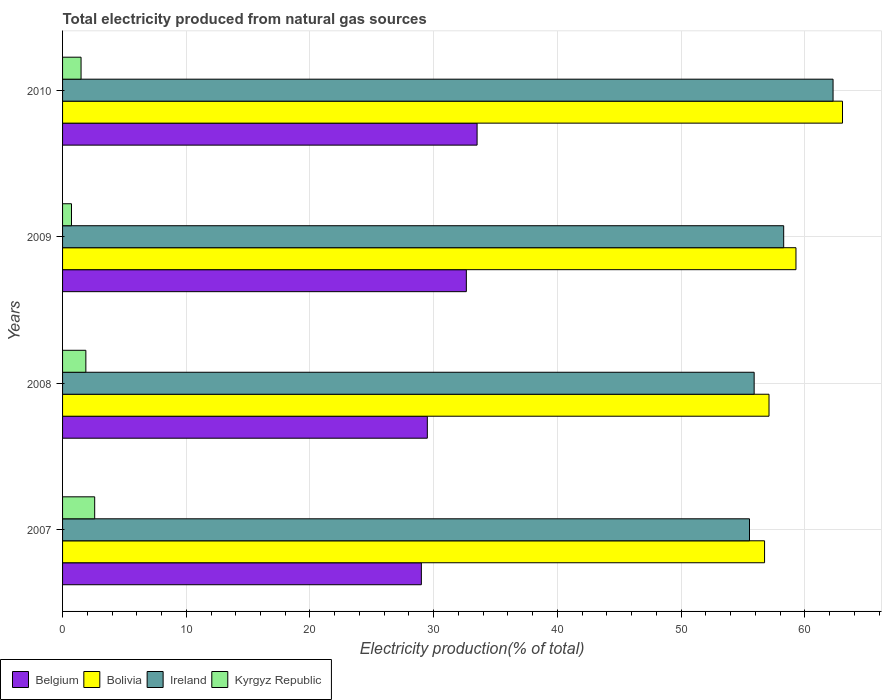Are the number of bars per tick equal to the number of legend labels?
Your response must be concise. Yes. Are the number of bars on each tick of the Y-axis equal?
Your answer should be compact. Yes. How many bars are there on the 3rd tick from the top?
Make the answer very short. 4. In how many cases, is the number of bars for a given year not equal to the number of legend labels?
Offer a terse response. 0. What is the total electricity produced in Bolivia in 2008?
Provide a succinct answer. 57.11. Across all years, what is the maximum total electricity produced in Bolivia?
Offer a terse response. 63.05. Across all years, what is the minimum total electricity produced in Belgium?
Make the answer very short. 29. In which year was the total electricity produced in Kyrgyz Republic maximum?
Provide a succinct answer. 2007. In which year was the total electricity produced in Belgium minimum?
Give a very brief answer. 2007. What is the total total electricity produced in Belgium in the graph?
Offer a terse response. 124.64. What is the difference between the total electricity produced in Kyrgyz Republic in 2007 and that in 2010?
Give a very brief answer. 1.1. What is the difference between the total electricity produced in Bolivia in 2008 and the total electricity produced in Belgium in 2007?
Your answer should be very brief. 28.1. What is the average total electricity produced in Belgium per year?
Your response must be concise. 31.16. In the year 2010, what is the difference between the total electricity produced in Bolivia and total electricity produced in Kyrgyz Republic?
Your answer should be compact. 61.55. What is the ratio of the total electricity produced in Bolivia in 2009 to that in 2010?
Your response must be concise. 0.94. Is the difference between the total electricity produced in Bolivia in 2007 and 2008 greater than the difference between the total electricity produced in Kyrgyz Republic in 2007 and 2008?
Make the answer very short. No. What is the difference between the highest and the second highest total electricity produced in Belgium?
Provide a short and direct response. 0.87. What is the difference between the highest and the lowest total electricity produced in Bolivia?
Keep it short and to the point. 6.3. Is it the case that in every year, the sum of the total electricity produced in Belgium and total electricity produced in Ireland is greater than the sum of total electricity produced in Kyrgyz Republic and total electricity produced in Bolivia?
Provide a short and direct response. Yes. What does the 1st bar from the bottom in 2009 represents?
Give a very brief answer. Belgium. How many bars are there?
Provide a short and direct response. 16. How many years are there in the graph?
Offer a very short reply. 4. What is the difference between two consecutive major ticks on the X-axis?
Make the answer very short. 10. Does the graph contain any zero values?
Offer a very short reply. No. Where does the legend appear in the graph?
Your answer should be very brief. Bottom left. How many legend labels are there?
Give a very brief answer. 4. How are the legend labels stacked?
Ensure brevity in your answer.  Horizontal. What is the title of the graph?
Provide a short and direct response. Total electricity produced from natural gas sources. What is the label or title of the X-axis?
Offer a terse response. Electricity production(% of total). What is the Electricity production(% of total) in Belgium in 2007?
Ensure brevity in your answer.  29. What is the Electricity production(% of total) in Bolivia in 2007?
Keep it short and to the point. 56.75. What is the Electricity production(% of total) of Ireland in 2007?
Your answer should be compact. 55.53. What is the Electricity production(% of total) in Kyrgyz Republic in 2007?
Your response must be concise. 2.6. What is the Electricity production(% of total) in Belgium in 2008?
Offer a very short reply. 29.49. What is the Electricity production(% of total) in Bolivia in 2008?
Your answer should be compact. 57.11. What is the Electricity production(% of total) of Ireland in 2008?
Offer a terse response. 55.91. What is the Electricity production(% of total) in Kyrgyz Republic in 2008?
Your answer should be compact. 1.88. What is the Electricity production(% of total) of Belgium in 2009?
Your answer should be compact. 32.64. What is the Electricity production(% of total) in Bolivia in 2009?
Make the answer very short. 59.29. What is the Electricity production(% of total) of Ireland in 2009?
Your answer should be very brief. 58.29. What is the Electricity production(% of total) in Kyrgyz Republic in 2009?
Offer a terse response. 0.72. What is the Electricity production(% of total) in Belgium in 2010?
Provide a short and direct response. 33.51. What is the Electricity production(% of total) in Bolivia in 2010?
Keep it short and to the point. 63.05. What is the Electricity production(% of total) in Ireland in 2010?
Provide a succinct answer. 62.29. What is the Electricity production(% of total) of Kyrgyz Republic in 2010?
Provide a succinct answer. 1.5. Across all years, what is the maximum Electricity production(% of total) in Belgium?
Keep it short and to the point. 33.51. Across all years, what is the maximum Electricity production(% of total) in Bolivia?
Offer a terse response. 63.05. Across all years, what is the maximum Electricity production(% of total) in Ireland?
Ensure brevity in your answer.  62.29. Across all years, what is the maximum Electricity production(% of total) of Kyrgyz Republic?
Keep it short and to the point. 2.6. Across all years, what is the minimum Electricity production(% of total) of Belgium?
Ensure brevity in your answer.  29. Across all years, what is the minimum Electricity production(% of total) in Bolivia?
Your answer should be compact. 56.75. Across all years, what is the minimum Electricity production(% of total) of Ireland?
Keep it short and to the point. 55.53. Across all years, what is the minimum Electricity production(% of total) in Kyrgyz Republic?
Your answer should be compact. 0.72. What is the total Electricity production(% of total) of Belgium in the graph?
Ensure brevity in your answer.  124.64. What is the total Electricity production(% of total) in Bolivia in the graph?
Make the answer very short. 236.19. What is the total Electricity production(% of total) in Ireland in the graph?
Provide a short and direct response. 232.02. What is the total Electricity production(% of total) in Kyrgyz Republic in the graph?
Ensure brevity in your answer.  6.7. What is the difference between the Electricity production(% of total) of Belgium in 2007 and that in 2008?
Your answer should be very brief. -0.48. What is the difference between the Electricity production(% of total) in Bolivia in 2007 and that in 2008?
Provide a short and direct response. -0.36. What is the difference between the Electricity production(% of total) of Ireland in 2007 and that in 2008?
Make the answer very short. -0.38. What is the difference between the Electricity production(% of total) in Kyrgyz Republic in 2007 and that in 2008?
Your answer should be very brief. 0.71. What is the difference between the Electricity production(% of total) of Belgium in 2007 and that in 2009?
Provide a succinct answer. -3.64. What is the difference between the Electricity production(% of total) of Bolivia in 2007 and that in 2009?
Offer a very short reply. -2.54. What is the difference between the Electricity production(% of total) of Ireland in 2007 and that in 2009?
Offer a very short reply. -2.76. What is the difference between the Electricity production(% of total) in Kyrgyz Republic in 2007 and that in 2009?
Your response must be concise. 1.87. What is the difference between the Electricity production(% of total) of Belgium in 2007 and that in 2010?
Ensure brevity in your answer.  -4.51. What is the difference between the Electricity production(% of total) in Bolivia in 2007 and that in 2010?
Ensure brevity in your answer.  -6.3. What is the difference between the Electricity production(% of total) in Ireland in 2007 and that in 2010?
Your answer should be compact. -6.76. What is the difference between the Electricity production(% of total) of Kyrgyz Republic in 2007 and that in 2010?
Make the answer very short. 1.1. What is the difference between the Electricity production(% of total) of Belgium in 2008 and that in 2009?
Give a very brief answer. -3.15. What is the difference between the Electricity production(% of total) in Bolivia in 2008 and that in 2009?
Give a very brief answer. -2.18. What is the difference between the Electricity production(% of total) of Ireland in 2008 and that in 2009?
Make the answer very short. -2.39. What is the difference between the Electricity production(% of total) in Kyrgyz Republic in 2008 and that in 2009?
Your answer should be very brief. 1.16. What is the difference between the Electricity production(% of total) of Belgium in 2008 and that in 2010?
Your response must be concise. -4.02. What is the difference between the Electricity production(% of total) of Bolivia in 2008 and that in 2010?
Your response must be concise. -5.94. What is the difference between the Electricity production(% of total) of Ireland in 2008 and that in 2010?
Offer a very short reply. -6.38. What is the difference between the Electricity production(% of total) in Kyrgyz Republic in 2008 and that in 2010?
Your response must be concise. 0.39. What is the difference between the Electricity production(% of total) of Belgium in 2009 and that in 2010?
Your answer should be compact. -0.87. What is the difference between the Electricity production(% of total) of Bolivia in 2009 and that in 2010?
Provide a succinct answer. -3.76. What is the difference between the Electricity production(% of total) of Ireland in 2009 and that in 2010?
Offer a very short reply. -3.99. What is the difference between the Electricity production(% of total) in Kyrgyz Republic in 2009 and that in 2010?
Make the answer very short. -0.77. What is the difference between the Electricity production(% of total) of Belgium in 2007 and the Electricity production(% of total) of Bolivia in 2008?
Your answer should be very brief. -28.1. What is the difference between the Electricity production(% of total) of Belgium in 2007 and the Electricity production(% of total) of Ireland in 2008?
Offer a very short reply. -26.9. What is the difference between the Electricity production(% of total) of Belgium in 2007 and the Electricity production(% of total) of Kyrgyz Republic in 2008?
Make the answer very short. 27.12. What is the difference between the Electricity production(% of total) in Bolivia in 2007 and the Electricity production(% of total) in Ireland in 2008?
Make the answer very short. 0.84. What is the difference between the Electricity production(% of total) of Bolivia in 2007 and the Electricity production(% of total) of Kyrgyz Republic in 2008?
Provide a short and direct response. 54.87. What is the difference between the Electricity production(% of total) of Ireland in 2007 and the Electricity production(% of total) of Kyrgyz Republic in 2008?
Offer a terse response. 53.65. What is the difference between the Electricity production(% of total) of Belgium in 2007 and the Electricity production(% of total) of Bolivia in 2009?
Provide a short and direct response. -30.28. What is the difference between the Electricity production(% of total) of Belgium in 2007 and the Electricity production(% of total) of Ireland in 2009?
Ensure brevity in your answer.  -29.29. What is the difference between the Electricity production(% of total) of Belgium in 2007 and the Electricity production(% of total) of Kyrgyz Republic in 2009?
Your answer should be compact. 28.28. What is the difference between the Electricity production(% of total) of Bolivia in 2007 and the Electricity production(% of total) of Ireland in 2009?
Your answer should be compact. -1.55. What is the difference between the Electricity production(% of total) of Bolivia in 2007 and the Electricity production(% of total) of Kyrgyz Republic in 2009?
Make the answer very short. 56.03. What is the difference between the Electricity production(% of total) in Ireland in 2007 and the Electricity production(% of total) in Kyrgyz Republic in 2009?
Your response must be concise. 54.81. What is the difference between the Electricity production(% of total) of Belgium in 2007 and the Electricity production(% of total) of Bolivia in 2010?
Make the answer very short. -34.04. What is the difference between the Electricity production(% of total) in Belgium in 2007 and the Electricity production(% of total) in Ireland in 2010?
Ensure brevity in your answer.  -33.28. What is the difference between the Electricity production(% of total) of Belgium in 2007 and the Electricity production(% of total) of Kyrgyz Republic in 2010?
Your answer should be compact. 27.51. What is the difference between the Electricity production(% of total) of Bolivia in 2007 and the Electricity production(% of total) of Ireland in 2010?
Your answer should be compact. -5.54. What is the difference between the Electricity production(% of total) of Bolivia in 2007 and the Electricity production(% of total) of Kyrgyz Republic in 2010?
Keep it short and to the point. 55.25. What is the difference between the Electricity production(% of total) in Ireland in 2007 and the Electricity production(% of total) in Kyrgyz Republic in 2010?
Your answer should be very brief. 54.04. What is the difference between the Electricity production(% of total) of Belgium in 2008 and the Electricity production(% of total) of Bolivia in 2009?
Your response must be concise. -29.8. What is the difference between the Electricity production(% of total) in Belgium in 2008 and the Electricity production(% of total) in Ireland in 2009?
Keep it short and to the point. -28.81. What is the difference between the Electricity production(% of total) of Belgium in 2008 and the Electricity production(% of total) of Kyrgyz Republic in 2009?
Make the answer very short. 28.77. What is the difference between the Electricity production(% of total) in Bolivia in 2008 and the Electricity production(% of total) in Ireland in 2009?
Provide a succinct answer. -1.19. What is the difference between the Electricity production(% of total) of Bolivia in 2008 and the Electricity production(% of total) of Kyrgyz Republic in 2009?
Provide a succinct answer. 56.39. What is the difference between the Electricity production(% of total) in Ireland in 2008 and the Electricity production(% of total) in Kyrgyz Republic in 2009?
Your answer should be compact. 55.19. What is the difference between the Electricity production(% of total) of Belgium in 2008 and the Electricity production(% of total) of Bolivia in 2010?
Give a very brief answer. -33.56. What is the difference between the Electricity production(% of total) of Belgium in 2008 and the Electricity production(% of total) of Ireland in 2010?
Your response must be concise. -32.8. What is the difference between the Electricity production(% of total) in Belgium in 2008 and the Electricity production(% of total) in Kyrgyz Republic in 2010?
Offer a very short reply. 27.99. What is the difference between the Electricity production(% of total) of Bolivia in 2008 and the Electricity production(% of total) of Ireland in 2010?
Your answer should be very brief. -5.18. What is the difference between the Electricity production(% of total) of Bolivia in 2008 and the Electricity production(% of total) of Kyrgyz Republic in 2010?
Your answer should be compact. 55.61. What is the difference between the Electricity production(% of total) of Ireland in 2008 and the Electricity production(% of total) of Kyrgyz Republic in 2010?
Keep it short and to the point. 54.41. What is the difference between the Electricity production(% of total) of Belgium in 2009 and the Electricity production(% of total) of Bolivia in 2010?
Provide a succinct answer. -30.41. What is the difference between the Electricity production(% of total) in Belgium in 2009 and the Electricity production(% of total) in Ireland in 2010?
Give a very brief answer. -29.65. What is the difference between the Electricity production(% of total) of Belgium in 2009 and the Electricity production(% of total) of Kyrgyz Republic in 2010?
Provide a short and direct response. 31.14. What is the difference between the Electricity production(% of total) of Bolivia in 2009 and the Electricity production(% of total) of Ireland in 2010?
Offer a very short reply. -3. What is the difference between the Electricity production(% of total) in Bolivia in 2009 and the Electricity production(% of total) in Kyrgyz Republic in 2010?
Your response must be concise. 57.79. What is the difference between the Electricity production(% of total) of Ireland in 2009 and the Electricity production(% of total) of Kyrgyz Republic in 2010?
Your response must be concise. 56.8. What is the average Electricity production(% of total) of Belgium per year?
Offer a very short reply. 31.16. What is the average Electricity production(% of total) of Bolivia per year?
Provide a short and direct response. 59.05. What is the average Electricity production(% of total) in Ireland per year?
Give a very brief answer. 58.01. What is the average Electricity production(% of total) of Kyrgyz Republic per year?
Keep it short and to the point. 1.67. In the year 2007, what is the difference between the Electricity production(% of total) in Belgium and Electricity production(% of total) in Bolivia?
Provide a succinct answer. -27.75. In the year 2007, what is the difference between the Electricity production(% of total) of Belgium and Electricity production(% of total) of Ireland?
Offer a very short reply. -26.53. In the year 2007, what is the difference between the Electricity production(% of total) of Belgium and Electricity production(% of total) of Kyrgyz Republic?
Your response must be concise. 26.41. In the year 2007, what is the difference between the Electricity production(% of total) in Bolivia and Electricity production(% of total) in Ireland?
Your answer should be compact. 1.22. In the year 2007, what is the difference between the Electricity production(% of total) of Bolivia and Electricity production(% of total) of Kyrgyz Republic?
Make the answer very short. 54.15. In the year 2007, what is the difference between the Electricity production(% of total) in Ireland and Electricity production(% of total) in Kyrgyz Republic?
Ensure brevity in your answer.  52.94. In the year 2008, what is the difference between the Electricity production(% of total) in Belgium and Electricity production(% of total) in Bolivia?
Give a very brief answer. -27.62. In the year 2008, what is the difference between the Electricity production(% of total) in Belgium and Electricity production(% of total) in Ireland?
Your answer should be compact. -26.42. In the year 2008, what is the difference between the Electricity production(% of total) in Belgium and Electricity production(% of total) in Kyrgyz Republic?
Offer a terse response. 27.6. In the year 2008, what is the difference between the Electricity production(% of total) of Bolivia and Electricity production(% of total) of Ireland?
Offer a terse response. 1.2. In the year 2008, what is the difference between the Electricity production(% of total) of Bolivia and Electricity production(% of total) of Kyrgyz Republic?
Provide a short and direct response. 55.23. In the year 2008, what is the difference between the Electricity production(% of total) of Ireland and Electricity production(% of total) of Kyrgyz Republic?
Your response must be concise. 54.02. In the year 2009, what is the difference between the Electricity production(% of total) in Belgium and Electricity production(% of total) in Bolivia?
Give a very brief answer. -26.65. In the year 2009, what is the difference between the Electricity production(% of total) of Belgium and Electricity production(% of total) of Ireland?
Offer a terse response. -25.65. In the year 2009, what is the difference between the Electricity production(% of total) of Belgium and Electricity production(% of total) of Kyrgyz Republic?
Give a very brief answer. 31.92. In the year 2009, what is the difference between the Electricity production(% of total) of Bolivia and Electricity production(% of total) of Kyrgyz Republic?
Provide a succinct answer. 58.57. In the year 2009, what is the difference between the Electricity production(% of total) of Ireland and Electricity production(% of total) of Kyrgyz Republic?
Ensure brevity in your answer.  57.57. In the year 2010, what is the difference between the Electricity production(% of total) of Belgium and Electricity production(% of total) of Bolivia?
Give a very brief answer. -29.54. In the year 2010, what is the difference between the Electricity production(% of total) of Belgium and Electricity production(% of total) of Ireland?
Ensure brevity in your answer.  -28.78. In the year 2010, what is the difference between the Electricity production(% of total) in Belgium and Electricity production(% of total) in Kyrgyz Republic?
Your response must be concise. 32.01. In the year 2010, what is the difference between the Electricity production(% of total) in Bolivia and Electricity production(% of total) in Ireland?
Your answer should be compact. 0.76. In the year 2010, what is the difference between the Electricity production(% of total) of Bolivia and Electricity production(% of total) of Kyrgyz Republic?
Your response must be concise. 61.55. In the year 2010, what is the difference between the Electricity production(% of total) in Ireland and Electricity production(% of total) in Kyrgyz Republic?
Offer a very short reply. 60.79. What is the ratio of the Electricity production(% of total) in Belgium in 2007 to that in 2008?
Ensure brevity in your answer.  0.98. What is the ratio of the Electricity production(% of total) of Bolivia in 2007 to that in 2008?
Make the answer very short. 0.99. What is the ratio of the Electricity production(% of total) of Ireland in 2007 to that in 2008?
Offer a terse response. 0.99. What is the ratio of the Electricity production(% of total) of Kyrgyz Republic in 2007 to that in 2008?
Provide a short and direct response. 1.38. What is the ratio of the Electricity production(% of total) in Belgium in 2007 to that in 2009?
Offer a terse response. 0.89. What is the ratio of the Electricity production(% of total) of Bolivia in 2007 to that in 2009?
Offer a very short reply. 0.96. What is the ratio of the Electricity production(% of total) in Ireland in 2007 to that in 2009?
Keep it short and to the point. 0.95. What is the ratio of the Electricity production(% of total) of Kyrgyz Republic in 2007 to that in 2009?
Provide a short and direct response. 3.6. What is the ratio of the Electricity production(% of total) of Belgium in 2007 to that in 2010?
Your answer should be compact. 0.87. What is the ratio of the Electricity production(% of total) of Bolivia in 2007 to that in 2010?
Give a very brief answer. 0.9. What is the ratio of the Electricity production(% of total) in Ireland in 2007 to that in 2010?
Give a very brief answer. 0.89. What is the ratio of the Electricity production(% of total) of Kyrgyz Republic in 2007 to that in 2010?
Make the answer very short. 1.74. What is the ratio of the Electricity production(% of total) in Belgium in 2008 to that in 2009?
Make the answer very short. 0.9. What is the ratio of the Electricity production(% of total) of Bolivia in 2008 to that in 2009?
Offer a terse response. 0.96. What is the ratio of the Electricity production(% of total) of Ireland in 2008 to that in 2009?
Provide a short and direct response. 0.96. What is the ratio of the Electricity production(% of total) of Kyrgyz Republic in 2008 to that in 2009?
Make the answer very short. 2.61. What is the ratio of the Electricity production(% of total) of Belgium in 2008 to that in 2010?
Keep it short and to the point. 0.88. What is the ratio of the Electricity production(% of total) in Bolivia in 2008 to that in 2010?
Make the answer very short. 0.91. What is the ratio of the Electricity production(% of total) in Ireland in 2008 to that in 2010?
Offer a very short reply. 0.9. What is the ratio of the Electricity production(% of total) of Kyrgyz Republic in 2008 to that in 2010?
Keep it short and to the point. 1.26. What is the ratio of the Electricity production(% of total) in Belgium in 2009 to that in 2010?
Your answer should be compact. 0.97. What is the ratio of the Electricity production(% of total) of Bolivia in 2009 to that in 2010?
Provide a succinct answer. 0.94. What is the ratio of the Electricity production(% of total) of Ireland in 2009 to that in 2010?
Make the answer very short. 0.94. What is the ratio of the Electricity production(% of total) of Kyrgyz Republic in 2009 to that in 2010?
Keep it short and to the point. 0.48. What is the difference between the highest and the second highest Electricity production(% of total) in Belgium?
Offer a very short reply. 0.87. What is the difference between the highest and the second highest Electricity production(% of total) of Bolivia?
Keep it short and to the point. 3.76. What is the difference between the highest and the second highest Electricity production(% of total) in Ireland?
Offer a terse response. 3.99. What is the difference between the highest and the second highest Electricity production(% of total) of Kyrgyz Republic?
Ensure brevity in your answer.  0.71. What is the difference between the highest and the lowest Electricity production(% of total) of Belgium?
Provide a short and direct response. 4.51. What is the difference between the highest and the lowest Electricity production(% of total) of Bolivia?
Your response must be concise. 6.3. What is the difference between the highest and the lowest Electricity production(% of total) of Ireland?
Keep it short and to the point. 6.76. What is the difference between the highest and the lowest Electricity production(% of total) of Kyrgyz Republic?
Make the answer very short. 1.87. 